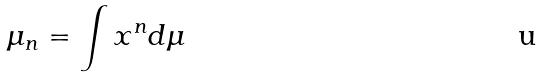Convert formula to latex. <formula><loc_0><loc_0><loc_500><loc_500>\mu _ { n } = \int x ^ { n } d \mu</formula> 